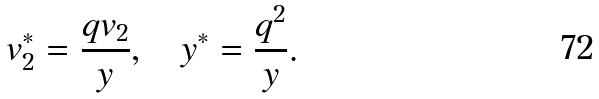<formula> <loc_0><loc_0><loc_500><loc_500>v _ { 2 } ^ { * } = \frac { q v _ { 2 } } { y } , \quad y ^ { * } = \frac { q ^ { 2 } } { y } .</formula> 